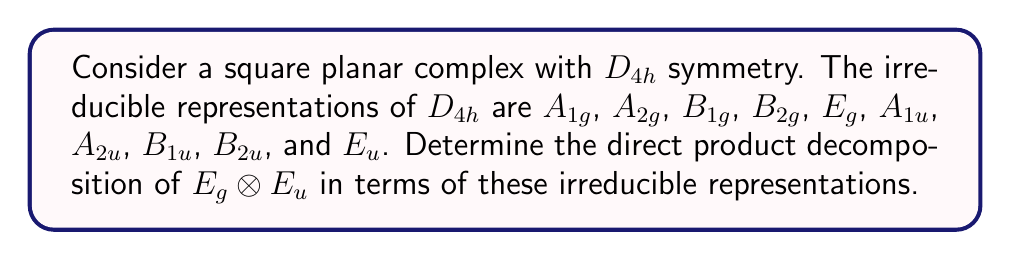Help me with this question. To compute the direct product decomposition, we follow these steps:

1) Recall the character multiplication table for $D_{4h}$. For $E_g \otimes E_u$, we need to multiply the characters of $E_g$ and $E_u$ for each symmetry operation.

2) The characters for $E_g$ and $E_u$ are:
   $E_g$: 2 2 0 0 0 2 0 0 2 -2
   $E_u$: 2 -2 0 0 0 -2 0 0 2 2

3) Multiply these characters:
   $E_g \otimes E_u$: 4 -4 0 0 0 -4 0 0 4 -4

4) Now, we need to determine which irreducible representations this product decomposes into. We use the formula:

   $$a_i = \frac{1}{h} \sum_R \chi(R) \chi_i(R)$$

   where $a_i$ is the number of times the $i$-th irreducible representation appears in the decomposition, $h$ is the order of the group (16 for $D_{4h}$), $\chi(R)$ is the character of our product for each symmetry operation $R$, and $\chi_i(R)$ is the character of the $i$-th irreducible representation for each $R$.

5) Calculating for each irreducible representation:

   $A_{1g}$: $\frac{1}{16}(4 + (-4) + 0 + 0 + 0 + (-4) + 0 + 0 + 4 + (-4)) = -\frac{1}{4}$
   $A_{2g}$: $\frac{1}{16}(4 + (-4) + 0 + 0 + 0 + (-4) + 0 + 0 + 4 + 4) = 0$
   $B_{1g}$: $\frac{1}{16}(4 + (-4) + 0 + 0 + 0 + 4 + 0 + 0 + 4 + (-4)) = \frac{1}{4}$
   $B_{2g}$: $\frac{1}{16}(4 + (-4) + 0 + 0 + 0 + 4 + 0 + 0 + 4 + 4) = \frac{1}{2}$
   $E_g$: $\frac{1}{16}(8 + (-8) + 0 + 0 + 0 + 0 + 0 + 0 + 8 + 0) = \frac{1}{2}$
   $A_{1u}$: $\frac{1}{16}(4 + 4 + 0 + 0 + 0 + (-4) + 0 + 0 + 4 + (-4)) = \frac{1}{4}$
   $A_{2u}$: $\frac{1}{16}(4 + 4 + 0 + 0 + 0 + (-4) + 0 + 0 + 4 + 4) = \frac{1}{2}$
   $B_{1u}$: $\frac{1}{16}(4 + 4 + 0 + 0 + 0 + 4 + 0 + 0 + 4 + (-4)) = \frac{3}{4}$
   $B_{2u}$: $\frac{1}{16}(4 + 4 + 0 + 0 + 0 + 4 + 0 + 0 + 4 + 4) = 1$
   $E_u$: $\frac{1}{16}(8 + (-8) + 0 + 0 + 0 + 0 + 0 + 0 + 8 + 0) = \frac{1}{2}$

6) The non-zero integer values correspond to the irreducible representations in the decomposition.
Answer: $E_g \otimes E_u = B_{2g} \oplus E_g \oplus A_{2u} \oplus B_{1u} \oplus B_{2u} \oplus E_u$ 